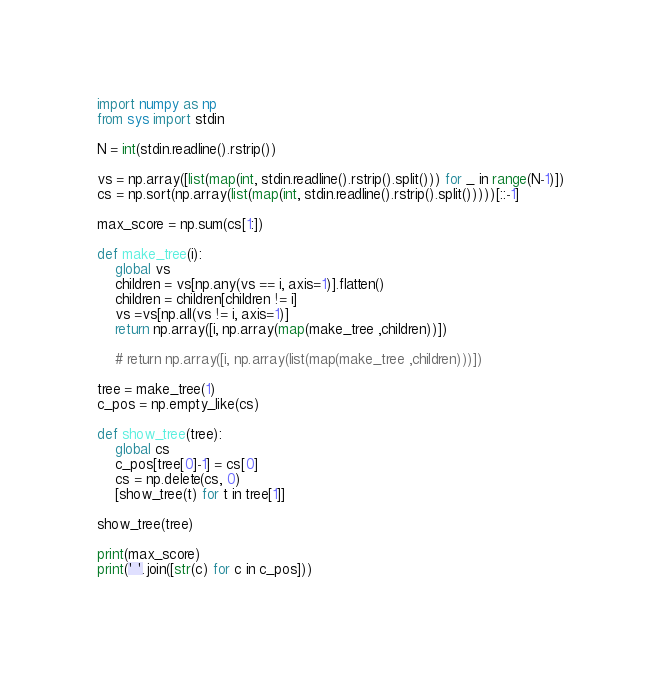<code> <loc_0><loc_0><loc_500><loc_500><_Python_>import numpy as np
from sys import stdin

N = int(stdin.readline().rstrip())

vs = np.array([list(map(int, stdin.readline().rstrip().split())) for _ in range(N-1)])
cs = np.sort(np.array(list(map(int, stdin.readline().rstrip().split()))))[::-1]

max_score = np.sum(cs[1:])

def make_tree(i):
    global vs
    children = vs[np.any(vs == i, axis=1)].flatten()
    children = children[children != i]
    vs =vs[np.all(vs != i, axis=1)]
    return np.array([i, np.array(map(make_tree ,children))])

    # return np.array([i, np.array(list(map(make_tree ,children)))])

tree = make_tree(1)
c_pos = np.empty_like(cs)

def show_tree(tree):
    global cs
    c_pos[tree[0]-1] = cs[0]
    cs = np.delete(cs, 0)
    [show_tree(t) for t in tree[1]]

show_tree(tree)

print(max_score)
print(' '.join([str(c) for c in c_pos]))
</code> 